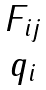<formula> <loc_0><loc_0><loc_500><loc_500>\begin{matrix} { { F } _ { i j } } \\ { { q } _ { i } } \\ \end{matrix}</formula> 